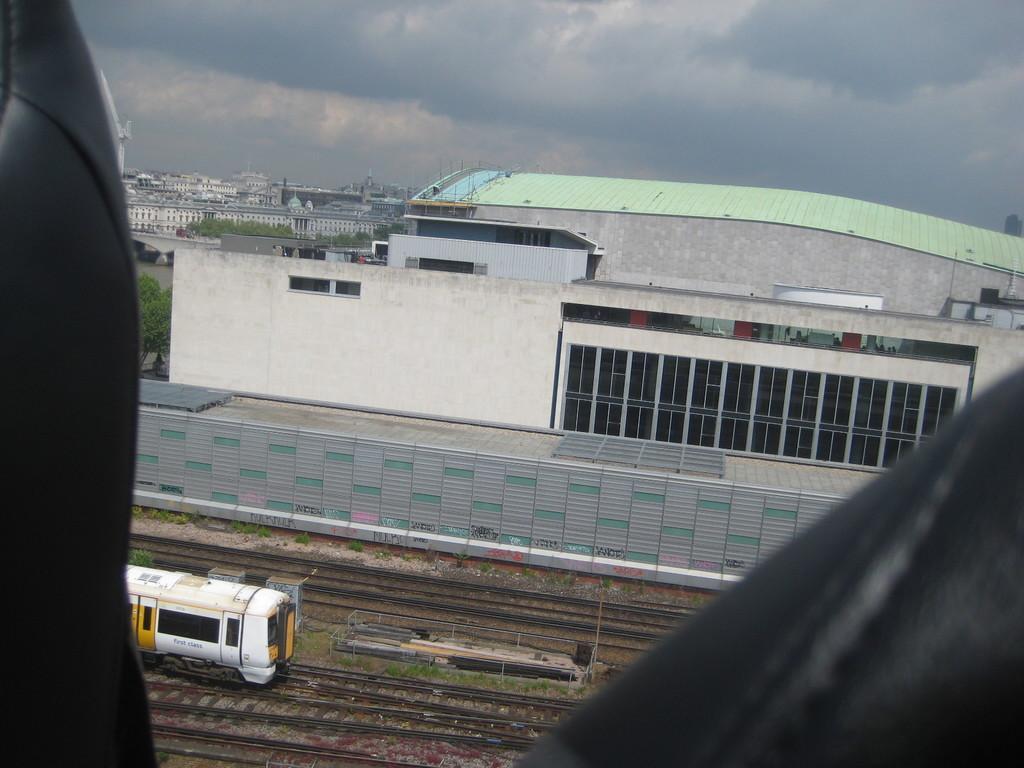How would you summarize this image in a sentence or two? In this image there are some objects in black color, at the center of the image there is a train on track and there are a few other tracks. In the background there are buildings, trees and sky. 